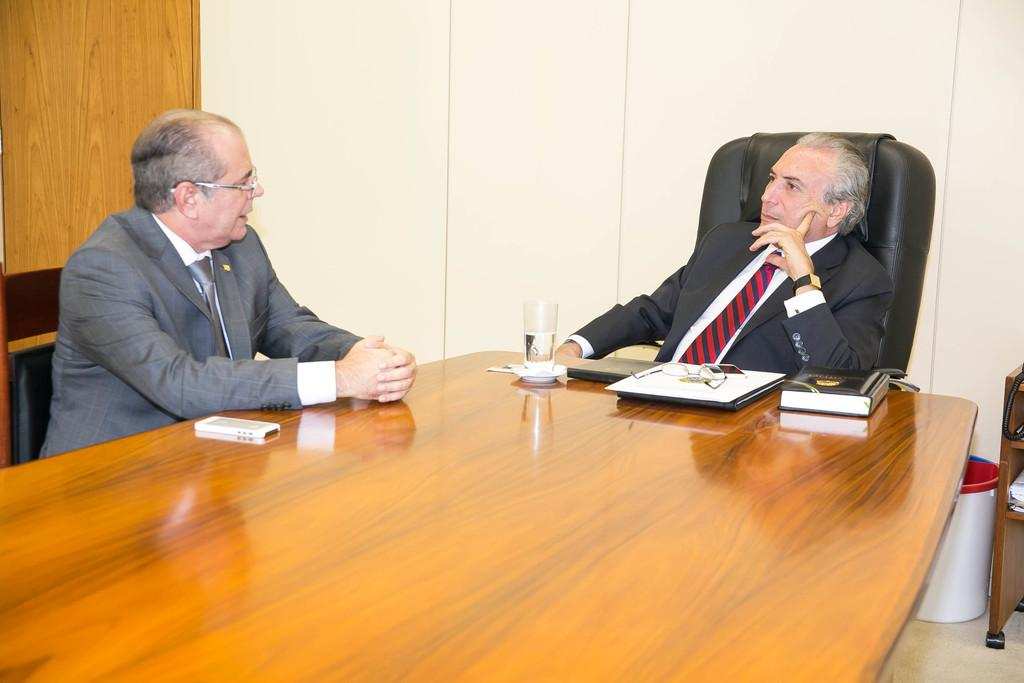How many people are in the image? There are two men in the image. What are the men doing in the image? The men are sitting in chairs and discussing something. What objects can be seen on the table in the image? There is a laptop, a book, a glass of water, and a mobile on the table. What type of stew is being served in the image? There is no stew present in the image. How many trucks can be seen in the background of the image? There are no trucks visible in the image. 